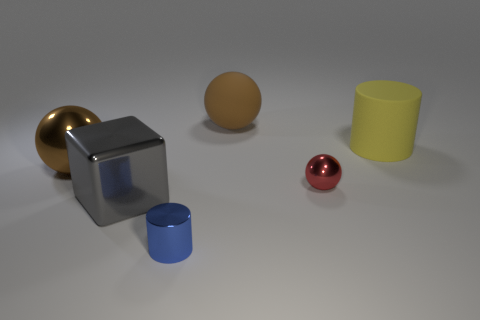Subtract all red cylinders. Subtract all yellow blocks. How many cylinders are left? 2 Add 1 yellow matte objects. How many objects exist? 7 Subtract all cylinders. How many objects are left? 4 Subtract all small brown blocks. Subtract all brown things. How many objects are left? 4 Add 2 blue shiny cylinders. How many blue shiny cylinders are left? 3 Add 3 big yellow objects. How many big yellow objects exist? 4 Subtract 0 green spheres. How many objects are left? 6 